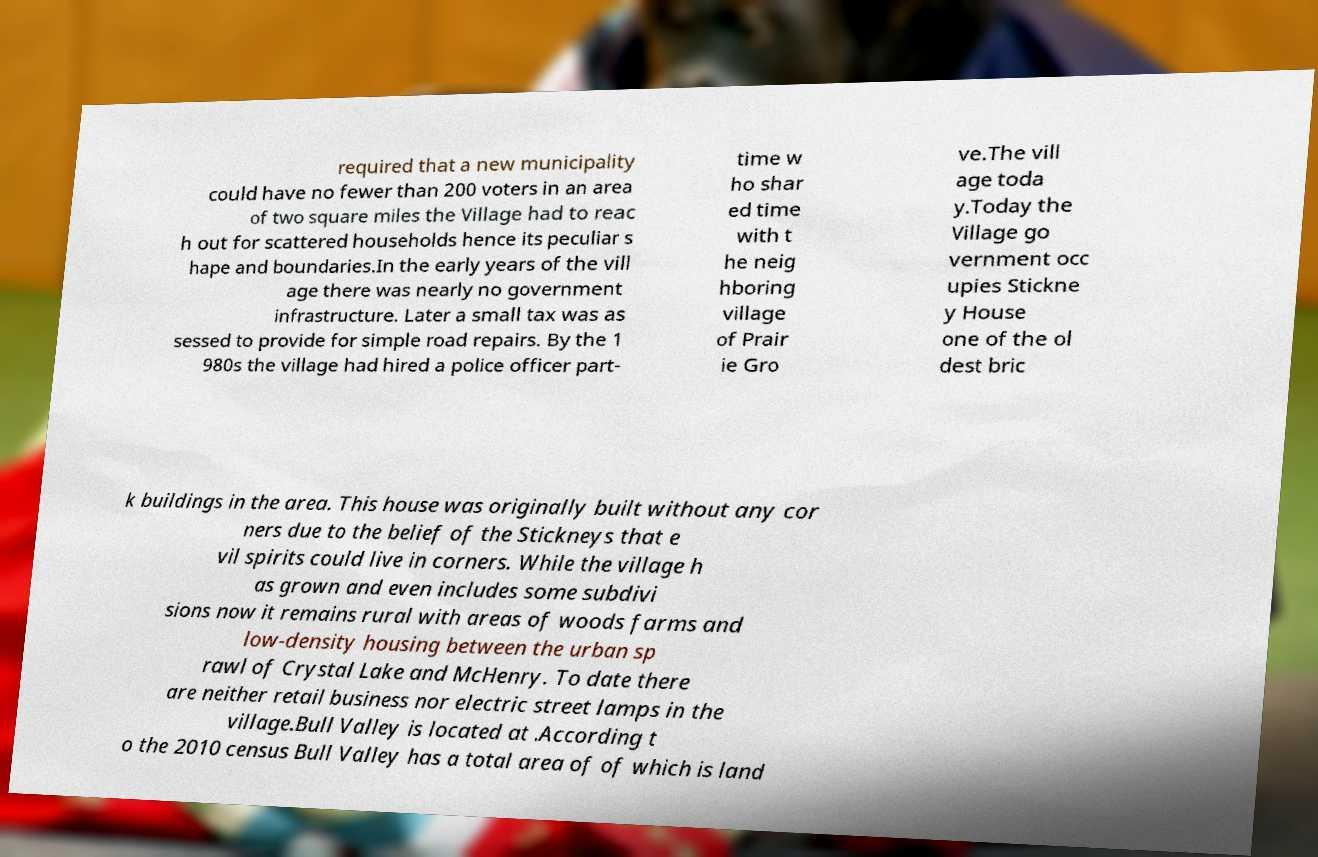Can you read and provide the text displayed in the image?This photo seems to have some interesting text. Can you extract and type it out for me? required that a new municipality could have no fewer than 200 voters in an area of two square miles the Village had to reac h out for scattered households hence its peculiar s hape and boundaries.In the early years of the vill age there was nearly no government infrastructure. Later a small tax was as sessed to provide for simple road repairs. By the 1 980s the village had hired a police officer part- time w ho shar ed time with t he neig hboring village of Prair ie Gro ve.The vill age toda y.Today the Village go vernment occ upies Stickne y House one of the ol dest bric k buildings in the area. This house was originally built without any cor ners due to the belief of the Stickneys that e vil spirits could live in corners. While the village h as grown and even includes some subdivi sions now it remains rural with areas of woods farms and low-density housing between the urban sp rawl of Crystal Lake and McHenry. To date there are neither retail business nor electric street lamps in the village.Bull Valley is located at .According t o the 2010 census Bull Valley has a total area of of which is land 